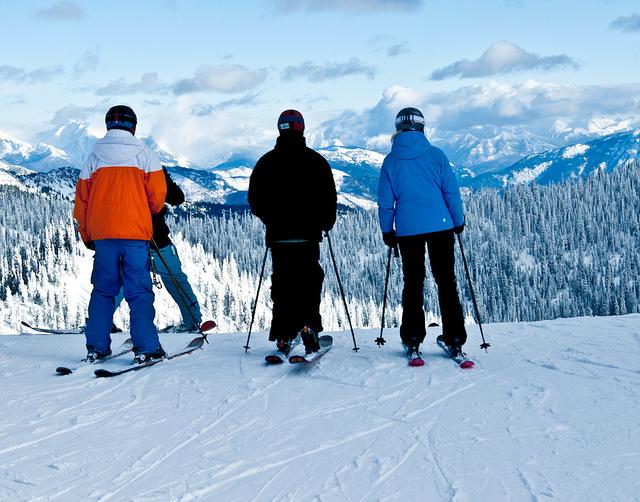What are in the sky?
Be succinct. Clouds. Is it cold?
Concise answer only. Yes. What are they doing?
Quick response, please. Skiing. 